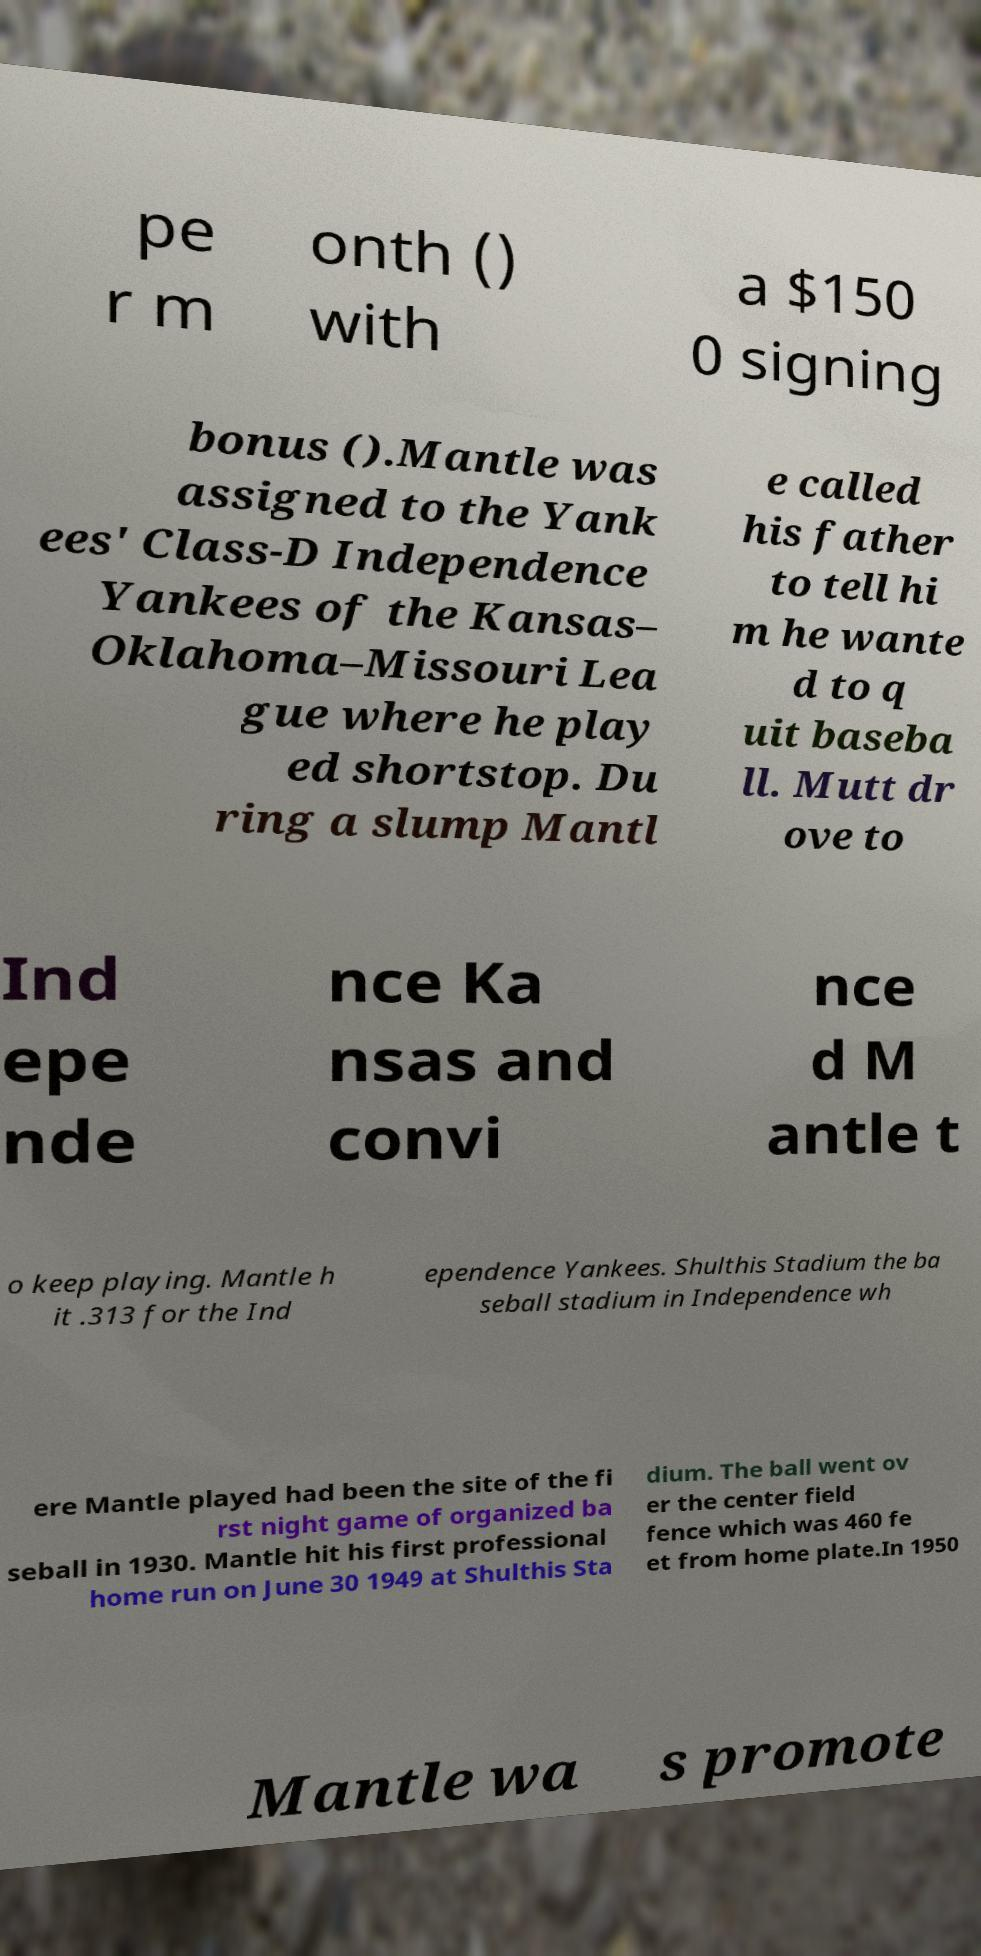There's text embedded in this image that I need extracted. Can you transcribe it verbatim? pe r m onth () with a $150 0 signing bonus ().Mantle was assigned to the Yank ees' Class-D Independence Yankees of the Kansas– Oklahoma–Missouri Lea gue where he play ed shortstop. Du ring a slump Mantl e called his father to tell hi m he wante d to q uit baseba ll. Mutt dr ove to Ind epe nde nce Ka nsas and convi nce d M antle t o keep playing. Mantle h it .313 for the Ind ependence Yankees. Shulthis Stadium the ba seball stadium in Independence wh ere Mantle played had been the site of the fi rst night game of organized ba seball in 1930. Mantle hit his first professional home run on June 30 1949 at Shulthis Sta dium. The ball went ov er the center field fence which was 460 fe et from home plate.In 1950 Mantle wa s promote 